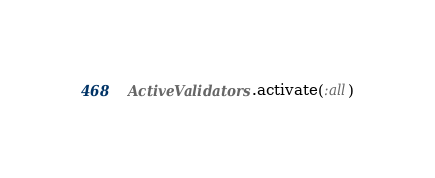<code> <loc_0><loc_0><loc_500><loc_500><_Ruby_>ActiveValidators.activate(:all)
</code> 